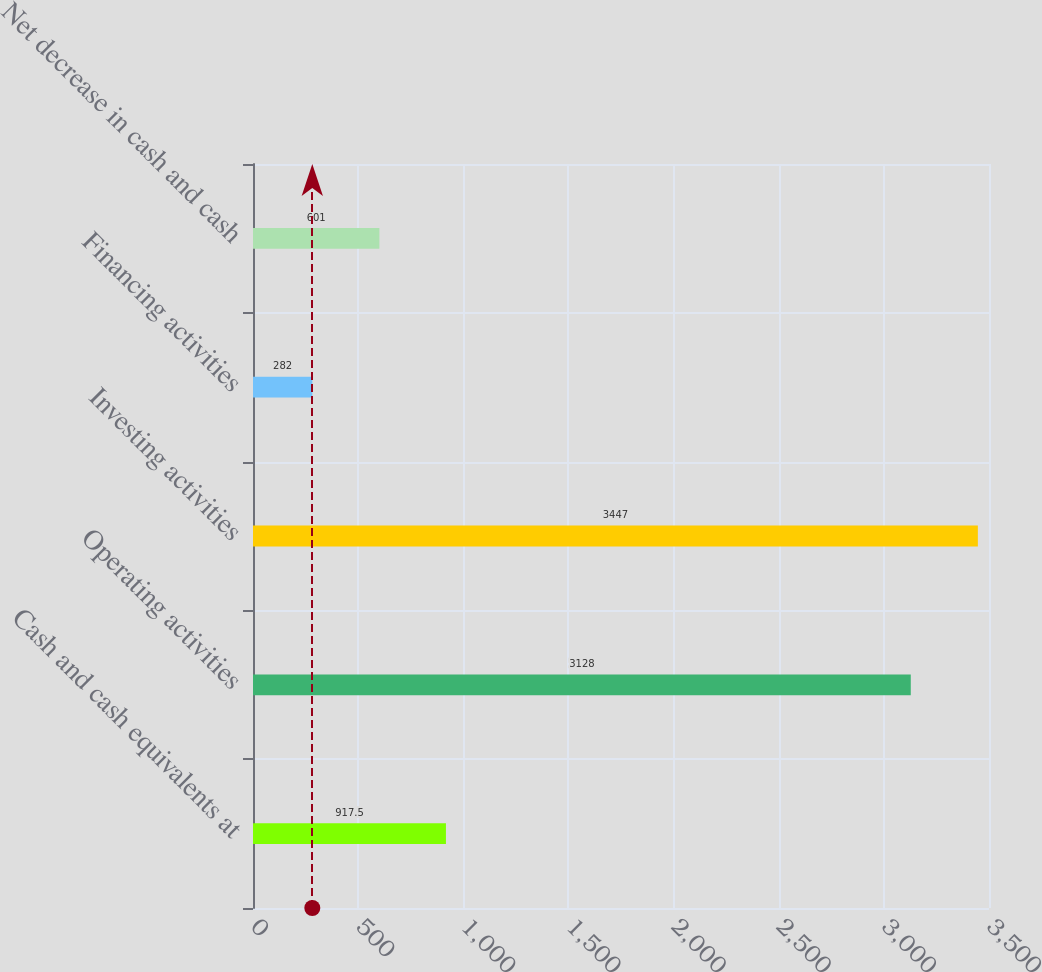<chart> <loc_0><loc_0><loc_500><loc_500><bar_chart><fcel>Cash and cash equivalents at<fcel>Operating activities<fcel>Investing activities<fcel>Financing activities<fcel>Net decrease in cash and cash<nl><fcel>917.5<fcel>3128<fcel>3447<fcel>282<fcel>601<nl></chart> 